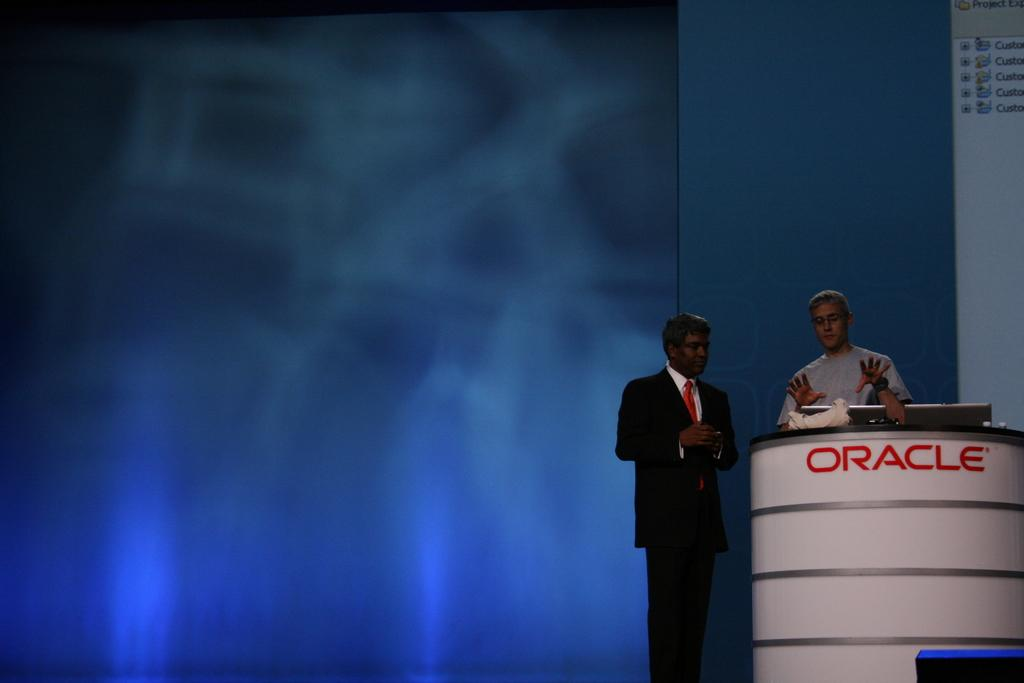How many men are standing in the image? There are two men standing in the image. What can be seen behind the men? There is a podium in the image. What is placed on the podium? Two laptops and a paper are placed on the podium. What is the color of the screen in the image? The screen appears to be bluish in color. Where is the drawer located in the image? There is no drawer present in the image. What type of loss is depicted in the image? There is no loss depicted in the image; it features two men standing near a podium with laptops and a paper. 